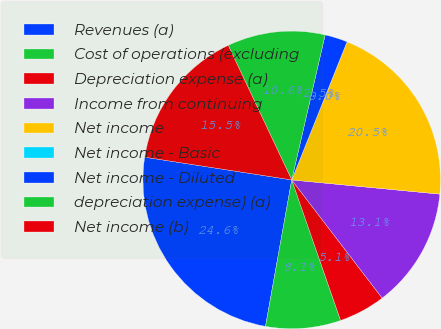Convert chart. <chart><loc_0><loc_0><loc_500><loc_500><pie_chart><fcel>Revenues (a)<fcel>Cost of operations (excluding<fcel>Depreciation expense (a)<fcel>Income from continuing<fcel>Net income<fcel>Net income - Basic<fcel>Net income - Diluted<fcel>depreciation expense) (a)<fcel>Net income (b)<nl><fcel>24.62%<fcel>8.15%<fcel>5.07%<fcel>13.08%<fcel>20.46%<fcel>0.0%<fcel>2.46%<fcel>10.62%<fcel>15.54%<nl></chart> 